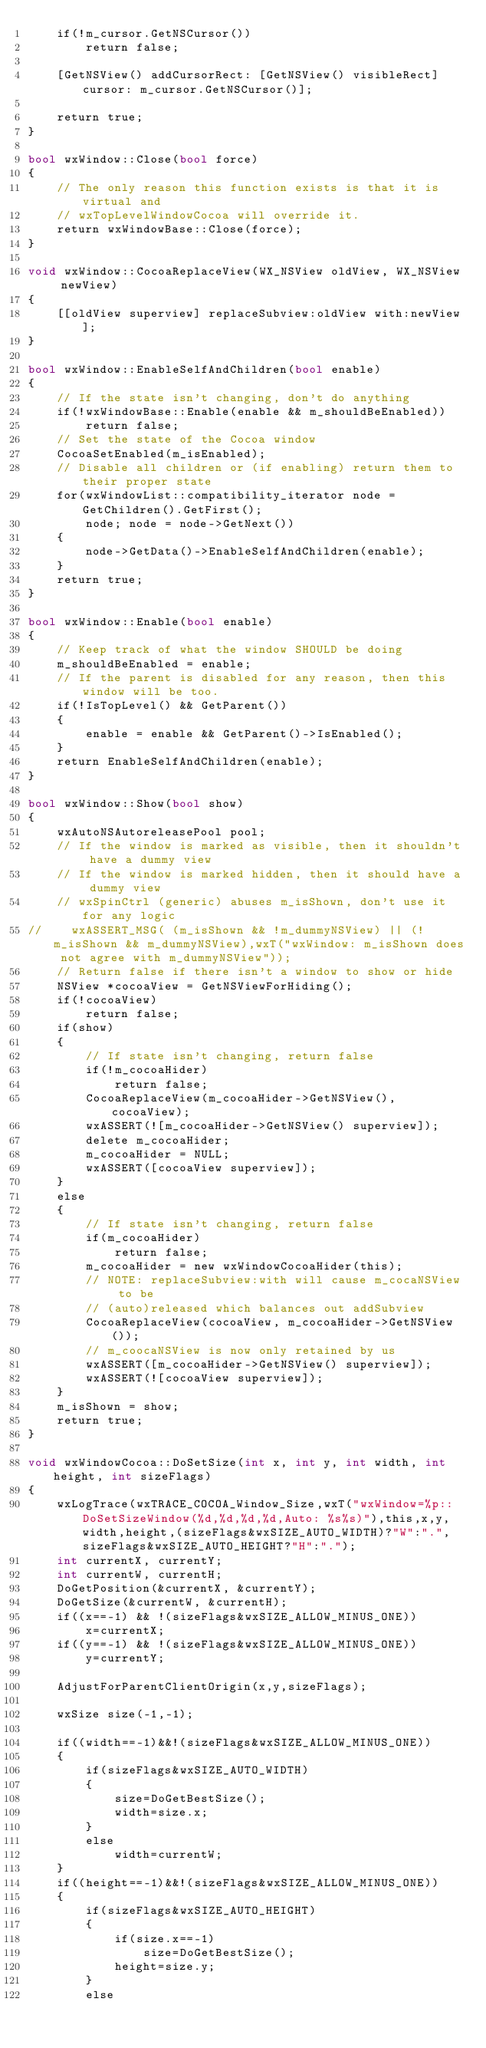Convert code to text. <code><loc_0><loc_0><loc_500><loc_500><_ObjectiveC_>    if(!m_cursor.GetNSCursor())
        return false;
    
    [GetNSView() addCursorRect: [GetNSView() visibleRect]  cursor: m_cursor.GetNSCursor()];    
        
    return true;
}

bool wxWindow::Close(bool force)
{
    // The only reason this function exists is that it is virtual and
    // wxTopLevelWindowCocoa will override it.
    return wxWindowBase::Close(force);
}

void wxWindow::CocoaReplaceView(WX_NSView oldView, WX_NSView newView)
{
    [[oldView superview] replaceSubview:oldView with:newView];
}

bool wxWindow::EnableSelfAndChildren(bool enable)
{
    // If the state isn't changing, don't do anything
    if(!wxWindowBase::Enable(enable && m_shouldBeEnabled))
        return false;
    // Set the state of the Cocoa window
    CocoaSetEnabled(m_isEnabled);
    // Disable all children or (if enabling) return them to their proper state
    for(wxWindowList::compatibility_iterator node = GetChildren().GetFirst();
        node; node = node->GetNext())
    {
        node->GetData()->EnableSelfAndChildren(enable);
    }
    return true;
}

bool wxWindow::Enable(bool enable)
{
    // Keep track of what the window SHOULD be doing
    m_shouldBeEnabled = enable;
    // If the parent is disabled for any reason, then this window will be too.
    if(!IsTopLevel() && GetParent())
    {
        enable = enable && GetParent()->IsEnabled();
    }
    return EnableSelfAndChildren(enable);
}

bool wxWindow::Show(bool show)
{
    wxAutoNSAutoreleasePool pool;
    // If the window is marked as visible, then it shouldn't have a dummy view
    // If the window is marked hidden, then it should have a dummy view
    // wxSpinCtrl (generic) abuses m_isShown, don't use it for any logic
//    wxASSERT_MSG( (m_isShown && !m_dummyNSView) || (!m_isShown && m_dummyNSView),wxT("wxWindow: m_isShown does not agree with m_dummyNSView"));
    // Return false if there isn't a window to show or hide
    NSView *cocoaView = GetNSViewForHiding();
    if(!cocoaView)
        return false;
    if(show)
    {
        // If state isn't changing, return false
        if(!m_cocoaHider)
            return false;
        CocoaReplaceView(m_cocoaHider->GetNSView(), cocoaView);
        wxASSERT(![m_cocoaHider->GetNSView() superview]);
        delete m_cocoaHider;
        m_cocoaHider = NULL;
        wxASSERT([cocoaView superview]);
    }
    else
    {
        // If state isn't changing, return false
        if(m_cocoaHider)
            return false;
        m_cocoaHider = new wxWindowCocoaHider(this);
        // NOTE: replaceSubview:with will cause m_cocaNSView to be
        // (auto)released which balances out addSubview
        CocoaReplaceView(cocoaView, m_cocoaHider->GetNSView());
        // m_coocaNSView is now only retained by us
        wxASSERT([m_cocoaHider->GetNSView() superview]);
        wxASSERT(![cocoaView superview]);
    }
    m_isShown = show;
    return true;
}

void wxWindowCocoa::DoSetSize(int x, int y, int width, int height, int sizeFlags)
{
    wxLogTrace(wxTRACE_COCOA_Window_Size,wxT("wxWindow=%p::DoSetSizeWindow(%d,%d,%d,%d,Auto: %s%s)"),this,x,y,width,height,(sizeFlags&wxSIZE_AUTO_WIDTH)?"W":".",sizeFlags&wxSIZE_AUTO_HEIGHT?"H":".");
    int currentX, currentY;
    int currentW, currentH;
    DoGetPosition(&currentX, &currentY);
    DoGetSize(&currentW, &currentH);
    if((x==-1) && !(sizeFlags&wxSIZE_ALLOW_MINUS_ONE))
        x=currentX;
    if((y==-1) && !(sizeFlags&wxSIZE_ALLOW_MINUS_ONE))
        y=currentY;

    AdjustForParentClientOrigin(x,y,sizeFlags);

    wxSize size(-1,-1);

    if((width==-1)&&!(sizeFlags&wxSIZE_ALLOW_MINUS_ONE))
    {
        if(sizeFlags&wxSIZE_AUTO_WIDTH)
        {
            size=DoGetBestSize();
            width=size.x;
        }
        else
            width=currentW;
    }
    if((height==-1)&&!(sizeFlags&wxSIZE_ALLOW_MINUS_ONE))
    {
        if(sizeFlags&wxSIZE_AUTO_HEIGHT)
        {
            if(size.x==-1)
                size=DoGetBestSize();
            height=size.y;
        }
        else</code> 